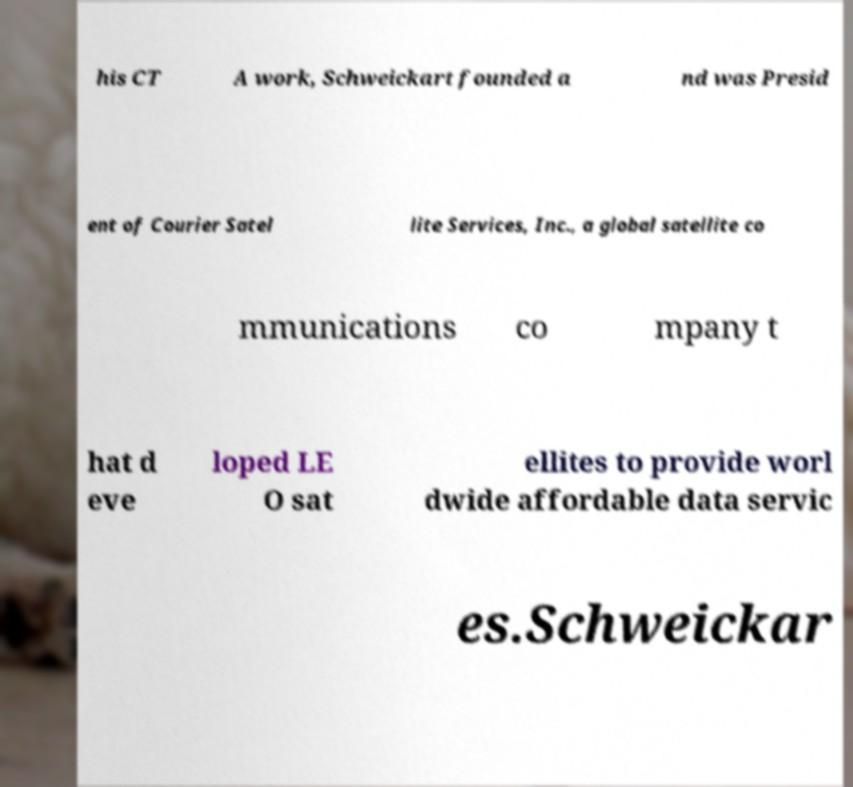For documentation purposes, I need the text within this image transcribed. Could you provide that? his CT A work, Schweickart founded a nd was Presid ent of Courier Satel lite Services, Inc., a global satellite co mmunications co mpany t hat d eve loped LE O sat ellites to provide worl dwide affordable data servic es.Schweickar 